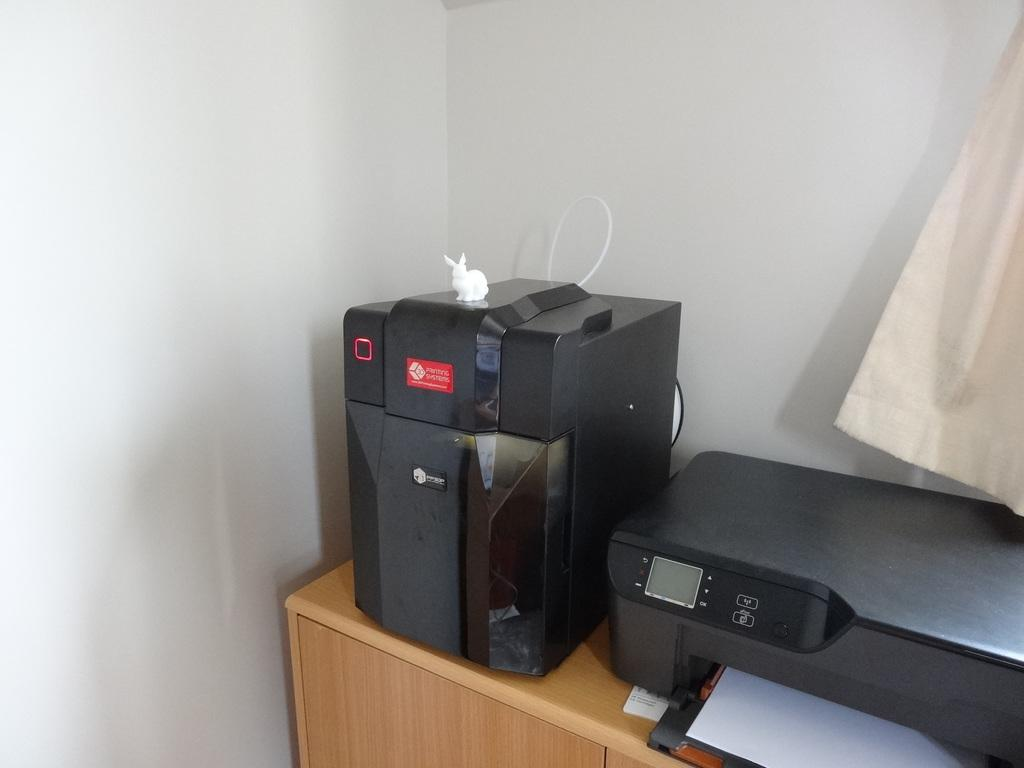What device is present in the image for amplifying sound? There is a loudspeaker in the image for amplifying sound. What type of animal can be seen in the image? There is a rabbit in the image. What machine is used for copying documents in the image? There is a xerox machine in the image for copying documents. What is on the desk in the image? There is a paper on the desk in the image. What type of material is present in the image? There is a cloth in the image. Can you see the seashore or ocean in the image? No, there is no seashore or ocean present in the image. Is there any indication of death or a funeral in the image? No, there is no indication of death or a funeral in the image. 